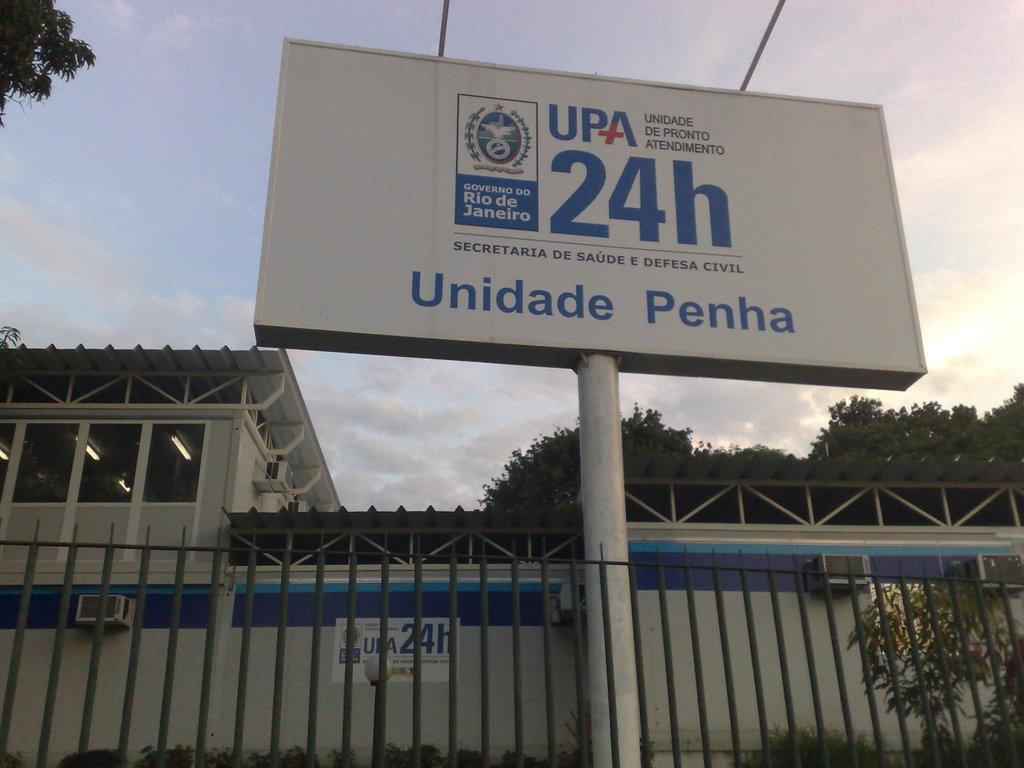Provide a one-sentence caption for the provided image. A white sign has the letters of UPA 24H displayed. 